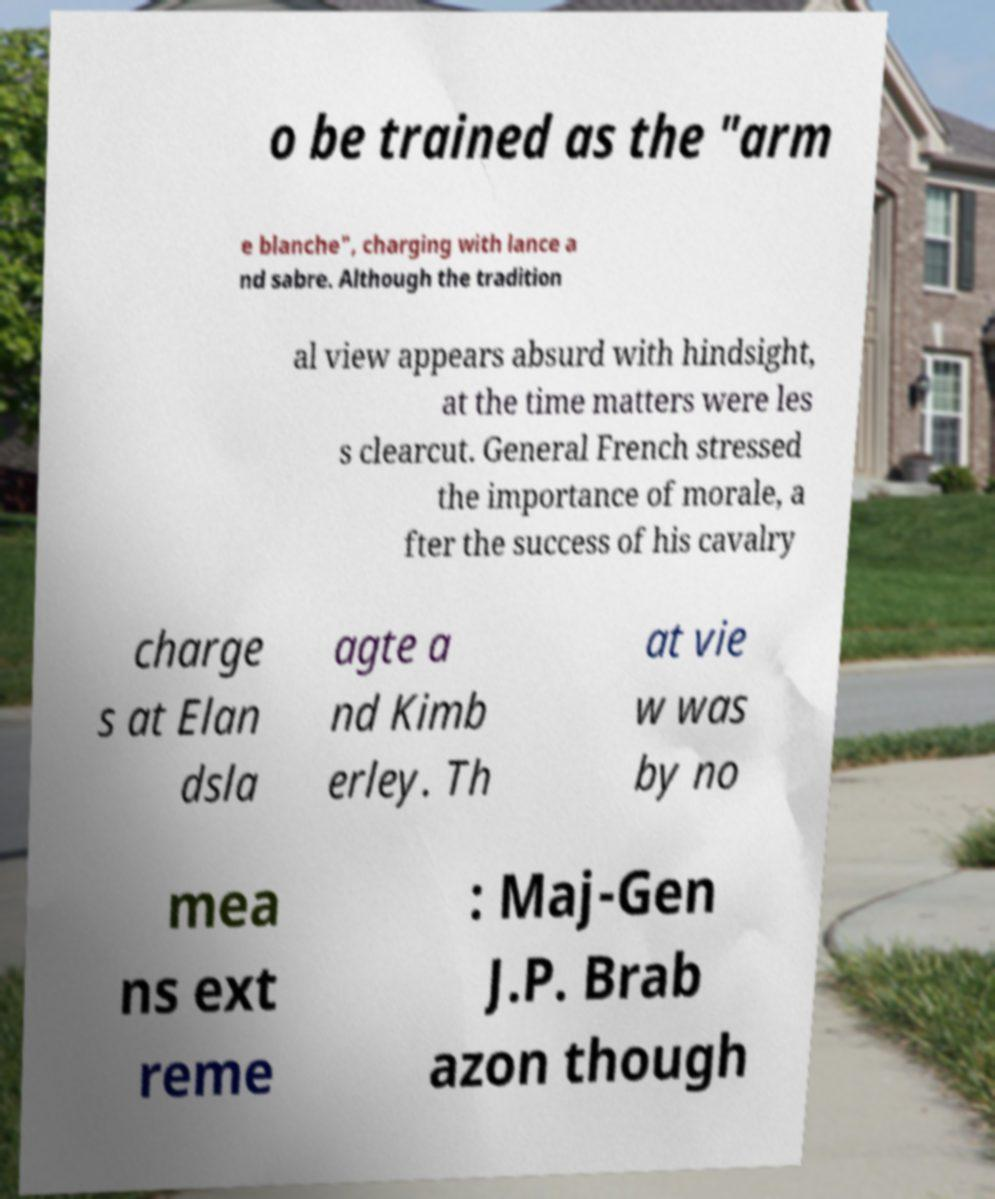Could you extract and type out the text from this image? o be trained as the "arm e blanche", charging with lance a nd sabre. Although the tradition al view appears absurd with hindsight, at the time matters were les s clearcut. General French stressed the importance of morale, a fter the success of his cavalry charge s at Elan dsla agte a nd Kimb erley. Th at vie w was by no mea ns ext reme : Maj-Gen J.P. Brab azon though 